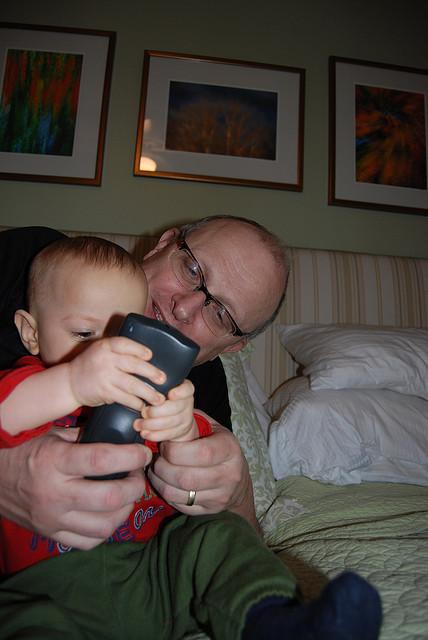What is the baby playing with? Please explain your reasoning. remote control. The baby is playing with a remote control to a tv or game. 